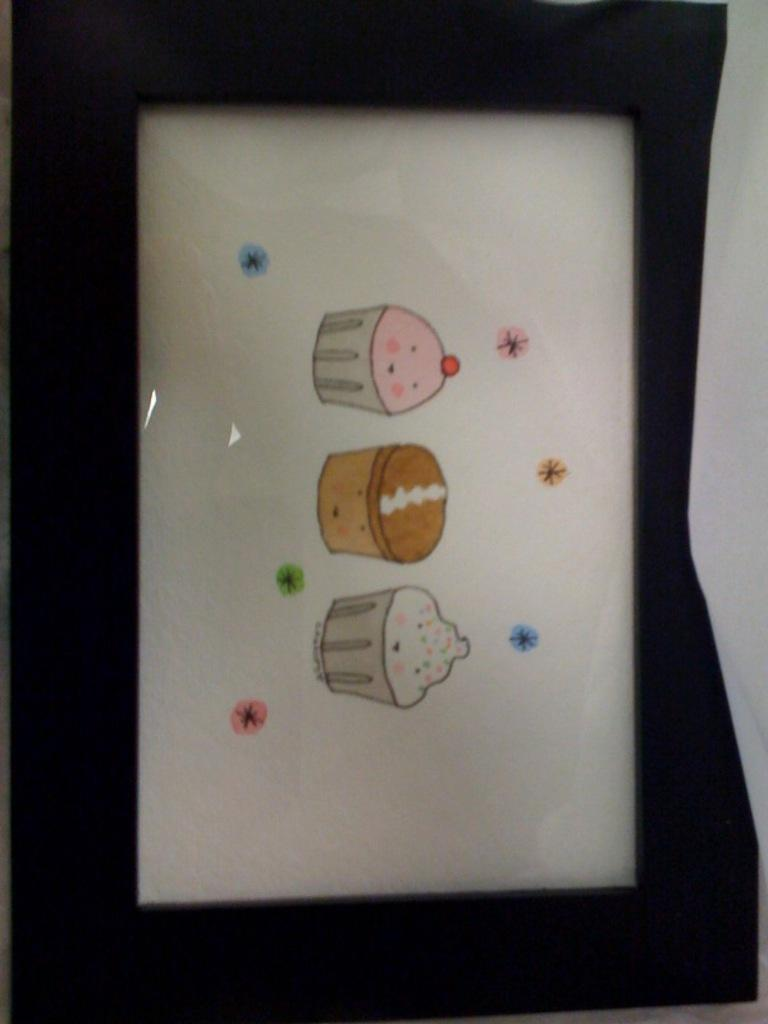What is the color of the object in the image? The object in the image is black. What type of object is it? The object appears to be a picture frame. What is depicted within the picture frame? There is a picture of three cupcakes within the frame. How many letters are visible on the cupcakes in the image? There are no letters visible on the cupcakes in the image; they are just depicted as images. 